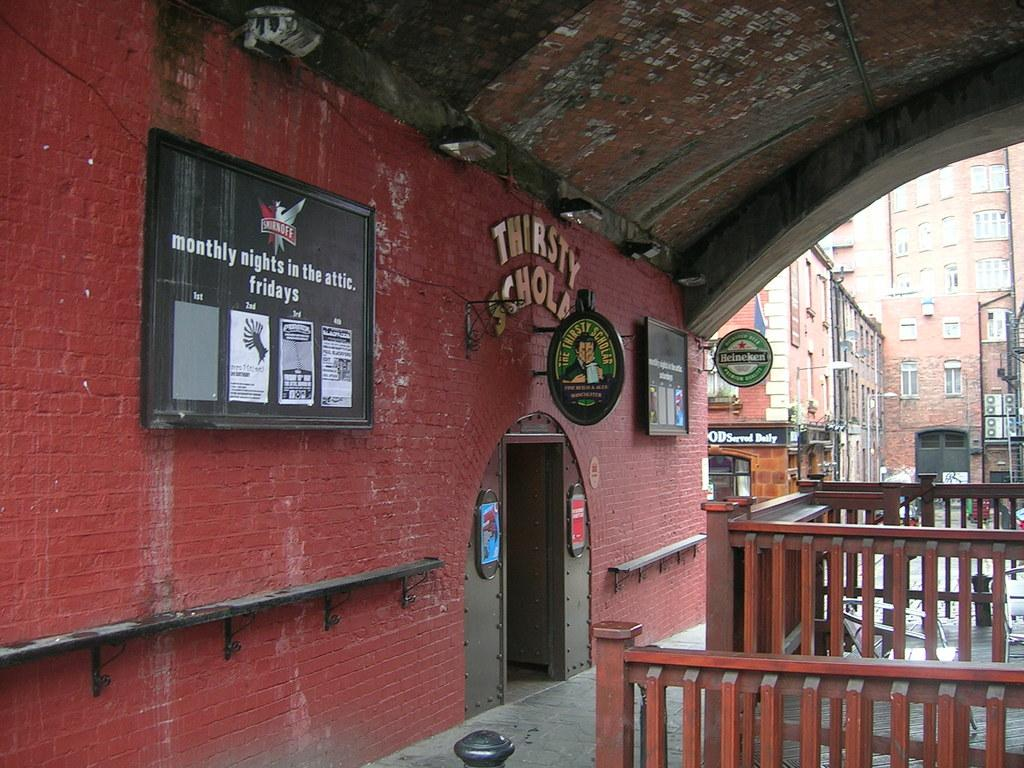What type of building is visible in the image? There is a building with a brick wall and a door in the image. What additional features can be seen on the building? There are boards on the building. What type of fencing is present in the image? There is wooden fencing in the image. What can be seen in the background of the image? In the background, there are buildings with windows and doors. Can you see the moon in the image? No, the moon is not visible in the image. Is there a goat or a rat present in the image? No, there are no animals, including goats or rats, present in the image. 